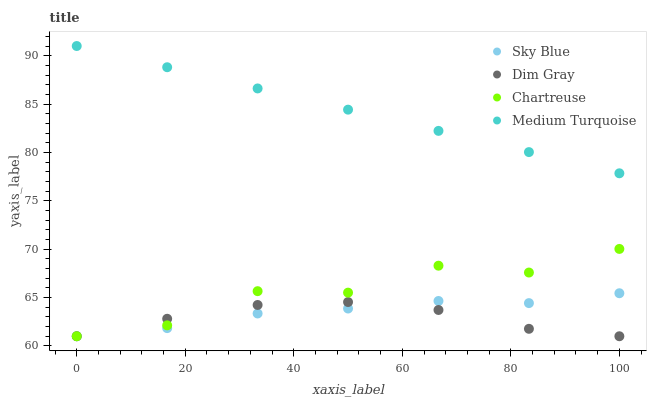Does Dim Gray have the minimum area under the curve?
Answer yes or no. Yes. Does Medium Turquoise have the maximum area under the curve?
Answer yes or no. Yes. Does Chartreuse have the minimum area under the curve?
Answer yes or no. No. Does Chartreuse have the maximum area under the curve?
Answer yes or no. No. Is Medium Turquoise the smoothest?
Answer yes or no. Yes. Is Chartreuse the roughest?
Answer yes or no. Yes. Is Dim Gray the smoothest?
Answer yes or no. No. Is Dim Gray the roughest?
Answer yes or no. No. Does Sky Blue have the lowest value?
Answer yes or no. Yes. Does Medium Turquoise have the lowest value?
Answer yes or no. No. Does Medium Turquoise have the highest value?
Answer yes or no. Yes. Does Chartreuse have the highest value?
Answer yes or no. No. Is Sky Blue less than Medium Turquoise?
Answer yes or no. Yes. Is Medium Turquoise greater than Chartreuse?
Answer yes or no. Yes. Does Dim Gray intersect Chartreuse?
Answer yes or no. Yes. Is Dim Gray less than Chartreuse?
Answer yes or no. No. Is Dim Gray greater than Chartreuse?
Answer yes or no. No. Does Sky Blue intersect Medium Turquoise?
Answer yes or no. No. 